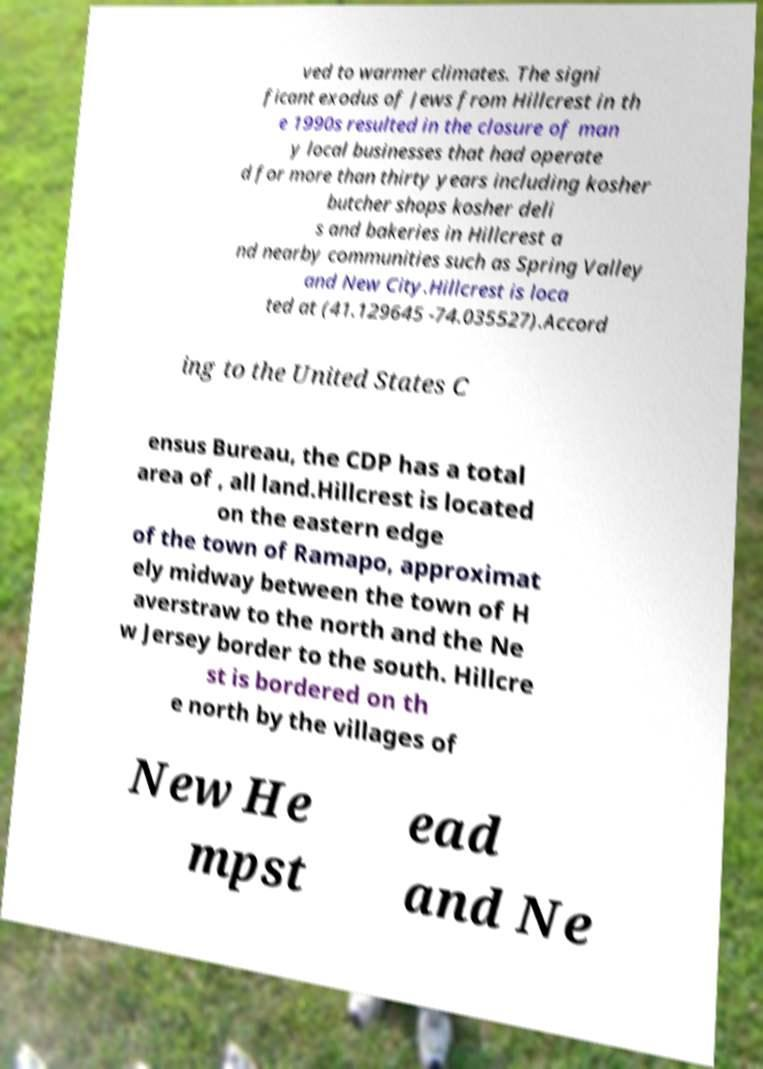For documentation purposes, I need the text within this image transcribed. Could you provide that? ved to warmer climates. The signi ficant exodus of Jews from Hillcrest in th e 1990s resulted in the closure of man y local businesses that had operate d for more than thirty years including kosher butcher shops kosher deli s and bakeries in Hillcrest a nd nearby communities such as Spring Valley and New City.Hillcrest is loca ted at (41.129645 -74.035527).Accord ing to the United States C ensus Bureau, the CDP has a total area of , all land.Hillcrest is located on the eastern edge of the town of Ramapo, approximat ely midway between the town of H averstraw to the north and the Ne w Jersey border to the south. Hillcre st is bordered on th e north by the villages of New He mpst ead and Ne 